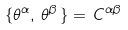<formula> <loc_0><loc_0><loc_500><loc_500>\{ \theta ^ { \alpha } , \, \theta ^ { \beta } \, \} = \, C ^ { \alpha \beta }</formula> 